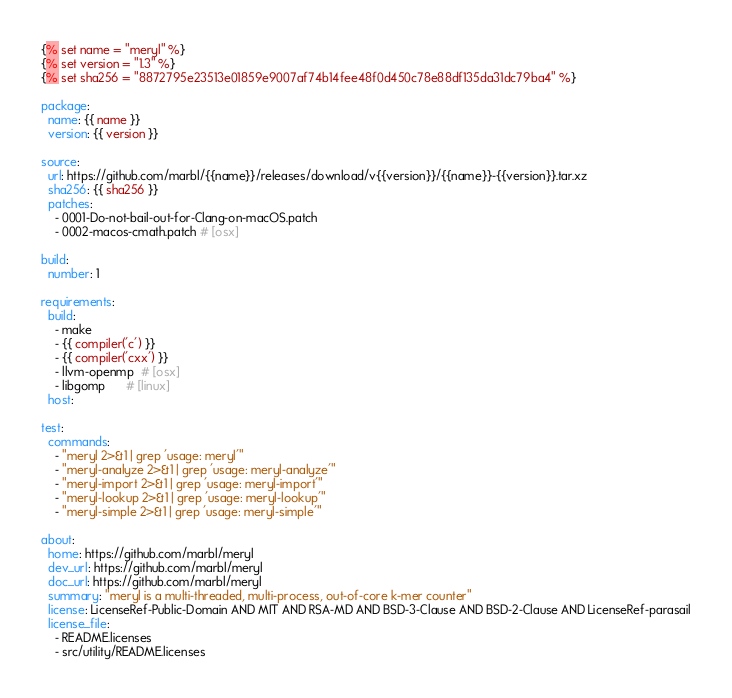<code> <loc_0><loc_0><loc_500><loc_500><_YAML_>{% set name = "meryl" %}
{% set version = "1.3" %}
{% set sha256 = "8872795e23513e01859e9007af74b14fee48f0d450c78e88df135da31dc79ba4" %}

package:
  name: {{ name }}
  version: {{ version }}

source:
  url: https://github.com/marbl/{{name}}/releases/download/v{{version}}/{{name}}-{{version}}.tar.xz
  sha256: {{ sha256 }}
  patches:
    - 0001-Do-not-bail-out-for-Clang-on-macOS.patch
    - 0002-macos-cmath.patch # [osx]

build:
  number: 1

requirements:
  build:
    - make
    - {{ compiler('c') }}
    - {{ compiler('cxx') }}
    - llvm-openmp  # [osx]
    - libgomp      # [linux]
  host:

test:
  commands:
    - "meryl 2>&1 | grep 'usage: meryl'"
    - "meryl-analyze 2>&1 | grep 'usage: meryl-analyze'"
    - "meryl-import 2>&1 | grep 'usage: meryl-import'"
    - "meryl-lookup 2>&1 | grep 'usage: meryl-lookup'"
    - "meryl-simple 2>&1 | grep 'usage: meryl-simple'"

about:
  home: https://github.com/marbl/meryl
  dev_url: https://github.com/marbl/meryl
  doc_url: https://github.com/marbl/meryl
  summary: "meryl is a multi-threaded, multi-process, out-of-core k-mer counter"
  license: LicenseRef-Public-Domain AND MIT AND RSA-MD AND BSD-3-Clause AND BSD-2-Clause AND LicenseRef-parasail
  license_file:
    - README.licenses
    - src/utility/README.licenses
</code> 